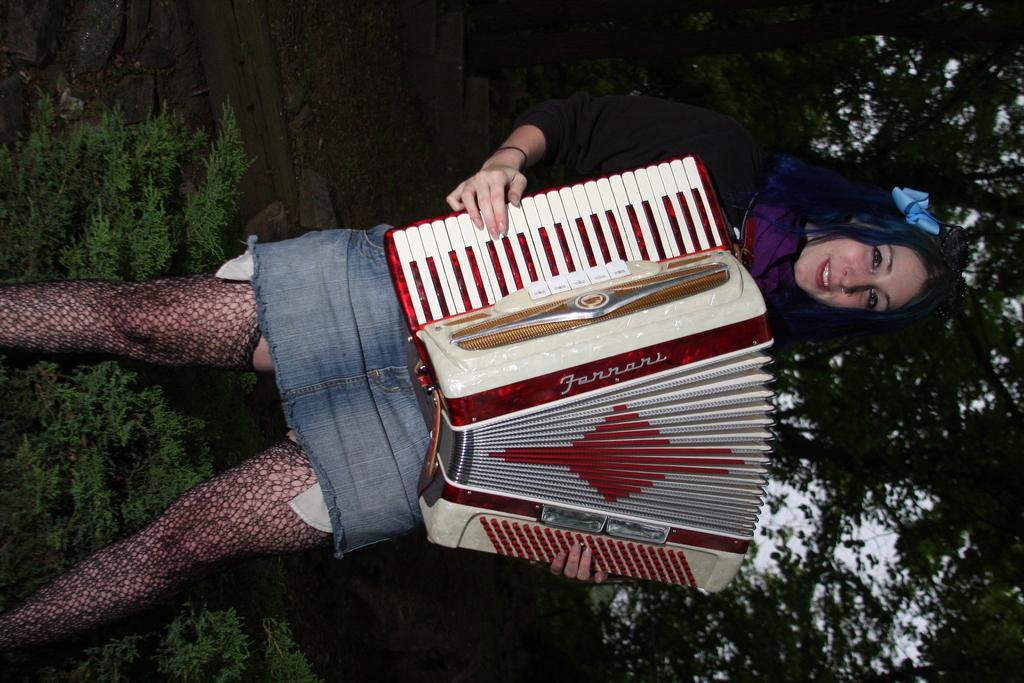Can you describe this image briefly? In the center of the image a lady is standing and holding a hohner. In the background of the image trees are there. At the bottom of the image plants are present. In the middle of the image ground is there. 